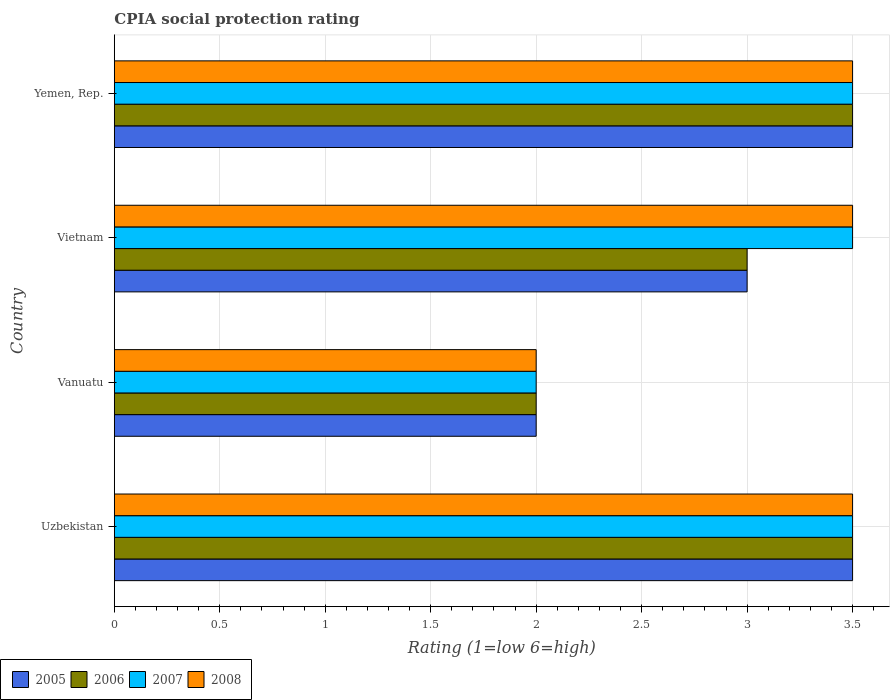How many different coloured bars are there?
Your answer should be compact. 4. How many groups of bars are there?
Provide a short and direct response. 4. Are the number of bars per tick equal to the number of legend labels?
Give a very brief answer. Yes. What is the label of the 2nd group of bars from the top?
Your answer should be compact. Vietnam. In how many cases, is the number of bars for a given country not equal to the number of legend labels?
Provide a short and direct response. 0. Across all countries, what is the minimum CPIA rating in 2008?
Ensure brevity in your answer.  2. In which country was the CPIA rating in 2007 maximum?
Offer a very short reply. Uzbekistan. In which country was the CPIA rating in 2008 minimum?
Make the answer very short. Vanuatu. What is the average CPIA rating in 2007 per country?
Your answer should be very brief. 3.12. What is the difference between the CPIA rating in 2006 and CPIA rating in 2005 in Vanuatu?
Make the answer very short. 0. In how many countries, is the CPIA rating in 2008 greater than 2.7 ?
Make the answer very short. 3. What is the ratio of the CPIA rating in 2007 in Vietnam to that in Yemen, Rep.?
Ensure brevity in your answer.  1. What is the difference between the highest and the second highest CPIA rating in 2007?
Offer a terse response. 0. What does the 2nd bar from the top in Vanuatu represents?
Offer a very short reply. 2007. What does the 2nd bar from the bottom in Uzbekistan represents?
Your answer should be compact. 2006. Is it the case that in every country, the sum of the CPIA rating in 2006 and CPIA rating in 2008 is greater than the CPIA rating in 2005?
Keep it short and to the point. Yes. How many bars are there?
Ensure brevity in your answer.  16. What is the difference between two consecutive major ticks on the X-axis?
Offer a terse response. 0.5. Are the values on the major ticks of X-axis written in scientific E-notation?
Offer a terse response. No. Does the graph contain any zero values?
Your answer should be very brief. No. Does the graph contain grids?
Give a very brief answer. Yes. How many legend labels are there?
Provide a succinct answer. 4. How are the legend labels stacked?
Your answer should be very brief. Horizontal. What is the title of the graph?
Provide a succinct answer. CPIA social protection rating. Does "1973" appear as one of the legend labels in the graph?
Provide a short and direct response. No. What is the label or title of the X-axis?
Your answer should be compact. Rating (1=low 6=high). What is the Rating (1=low 6=high) in 2007 in Uzbekistan?
Provide a short and direct response. 3.5. What is the Rating (1=low 6=high) of 2008 in Uzbekistan?
Make the answer very short. 3.5. What is the Rating (1=low 6=high) of 2005 in Vanuatu?
Provide a succinct answer. 2. What is the Rating (1=low 6=high) of 2005 in Vietnam?
Your response must be concise. 3. What is the Rating (1=low 6=high) of 2007 in Vietnam?
Offer a terse response. 3.5. What is the Rating (1=low 6=high) in 2008 in Vietnam?
Your answer should be very brief. 3.5. What is the Rating (1=low 6=high) in 2005 in Yemen, Rep.?
Provide a succinct answer. 3.5. What is the Rating (1=low 6=high) of 2007 in Yemen, Rep.?
Offer a very short reply. 3.5. Across all countries, what is the maximum Rating (1=low 6=high) of 2006?
Make the answer very short. 3.5. Across all countries, what is the maximum Rating (1=low 6=high) of 2007?
Your response must be concise. 3.5. Across all countries, what is the maximum Rating (1=low 6=high) of 2008?
Offer a terse response. 3.5. What is the total Rating (1=low 6=high) in 2005 in the graph?
Make the answer very short. 12. What is the total Rating (1=low 6=high) in 2008 in the graph?
Provide a short and direct response. 12.5. What is the difference between the Rating (1=low 6=high) of 2008 in Uzbekistan and that in Vanuatu?
Offer a very short reply. 1.5. What is the difference between the Rating (1=low 6=high) of 2006 in Uzbekistan and that in Vietnam?
Ensure brevity in your answer.  0.5. What is the difference between the Rating (1=low 6=high) of 2007 in Uzbekistan and that in Vietnam?
Provide a succinct answer. 0. What is the difference between the Rating (1=low 6=high) of 2005 in Uzbekistan and that in Yemen, Rep.?
Your response must be concise. 0. What is the difference between the Rating (1=low 6=high) of 2007 in Uzbekistan and that in Yemen, Rep.?
Your answer should be very brief. 0. What is the difference between the Rating (1=low 6=high) of 2005 in Vanuatu and that in Vietnam?
Ensure brevity in your answer.  -1. What is the difference between the Rating (1=low 6=high) in 2006 in Vanuatu and that in Vietnam?
Your answer should be compact. -1. What is the difference between the Rating (1=low 6=high) of 2005 in Vanuatu and that in Yemen, Rep.?
Give a very brief answer. -1.5. What is the difference between the Rating (1=low 6=high) in 2006 in Vanuatu and that in Yemen, Rep.?
Your answer should be very brief. -1.5. What is the difference between the Rating (1=low 6=high) of 2008 in Vanuatu and that in Yemen, Rep.?
Your answer should be compact. -1.5. What is the difference between the Rating (1=low 6=high) of 2005 in Vietnam and that in Yemen, Rep.?
Your response must be concise. -0.5. What is the difference between the Rating (1=low 6=high) in 2007 in Vietnam and that in Yemen, Rep.?
Make the answer very short. 0. What is the difference between the Rating (1=low 6=high) in 2005 in Uzbekistan and the Rating (1=low 6=high) in 2008 in Vanuatu?
Your answer should be compact. 1.5. What is the difference between the Rating (1=low 6=high) in 2005 in Uzbekistan and the Rating (1=low 6=high) in 2006 in Vietnam?
Your answer should be compact. 0.5. What is the difference between the Rating (1=low 6=high) of 2005 in Uzbekistan and the Rating (1=low 6=high) of 2007 in Vietnam?
Your answer should be compact. 0. What is the difference between the Rating (1=low 6=high) of 2005 in Uzbekistan and the Rating (1=low 6=high) of 2008 in Vietnam?
Keep it short and to the point. 0. What is the difference between the Rating (1=low 6=high) of 2006 in Uzbekistan and the Rating (1=low 6=high) of 2008 in Vietnam?
Your answer should be very brief. 0. What is the difference between the Rating (1=low 6=high) in 2005 in Uzbekistan and the Rating (1=low 6=high) in 2006 in Yemen, Rep.?
Keep it short and to the point. 0. What is the difference between the Rating (1=low 6=high) of 2005 in Vanuatu and the Rating (1=low 6=high) of 2006 in Vietnam?
Keep it short and to the point. -1. What is the difference between the Rating (1=low 6=high) of 2005 in Vanuatu and the Rating (1=low 6=high) of 2007 in Vietnam?
Give a very brief answer. -1.5. What is the difference between the Rating (1=low 6=high) of 2007 in Vanuatu and the Rating (1=low 6=high) of 2008 in Vietnam?
Make the answer very short. -1.5. What is the difference between the Rating (1=low 6=high) of 2005 in Vanuatu and the Rating (1=low 6=high) of 2007 in Yemen, Rep.?
Your answer should be very brief. -1.5. What is the difference between the Rating (1=low 6=high) in 2005 in Vanuatu and the Rating (1=low 6=high) in 2008 in Yemen, Rep.?
Give a very brief answer. -1.5. What is the difference between the Rating (1=low 6=high) of 2006 in Vanuatu and the Rating (1=low 6=high) of 2007 in Yemen, Rep.?
Your answer should be very brief. -1.5. What is the difference between the Rating (1=low 6=high) of 2005 in Vietnam and the Rating (1=low 6=high) of 2006 in Yemen, Rep.?
Provide a succinct answer. -0.5. What is the difference between the Rating (1=low 6=high) of 2005 in Vietnam and the Rating (1=low 6=high) of 2007 in Yemen, Rep.?
Give a very brief answer. -0.5. What is the difference between the Rating (1=low 6=high) in 2005 in Vietnam and the Rating (1=low 6=high) in 2008 in Yemen, Rep.?
Provide a short and direct response. -0.5. What is the difference between the Rating (1=low 6=high) in 2006 in Vietnam and the Rating (1=low 6=high) in 2007 in Yemen, Rep.?
Provide a succinct answer. -0.5. What is the difference between the Rating (1=low 6=high) in 2006 in Vietnam and the Rating (1=low 6=high) in 2008 in Yemen, Rep.?
Keep it short and to the point. -0.5. What is the difference between the Rating (1=low 6=high) in 2007 in Vietnam and the Rating (1=low 6=high) in 2008 in Yemen, Rep.?
Offer a terse response. 0. What is the average Rating (1=low 6=high) in 2006 per country?
Your response must be concise. 3. What is the average Rating (1=low 6=high) of 2007 per country?
Your answer should be very brief. 3.12. What is the average Rating (1=low 6=high) of 2008 per country?
Ensure brevity in your answer.  3.12. What is the difference between the Rating (1=low 6=high) in 2005 and Rating (1=low 6=high) in 2007 in Uzbekistan?
Keep it short and to the point. 0. What is the difference between the Rating (1=low 6=high) in 2006 and Rating (1=low 6=high) in 2008 in Uzbekistan?
Offer a very short reply. 0. What is the difference between the Rating (1=low 6=high) in 2007 and Rating (1=low 6=high) in 2008 in Uzbekistan?
Provide a succinct answer. 0. What is the difference between the Rating (1=low 6=high) of 2005 and Rating (1=low 6=high) of 2006 in Vanuatu?
Provide a succinct answer. 0. What is the difference between the Rating (1=low 6=high) in 2005 and Rating (1=low 6=high) in 2007 in Vanuatu?
Make the answer very short. 0. What is the difference between the Rating (1=low 6=high) in 2005 and Rating (1=low 6=high) in 2008 in Vanuatu?
Ensure brevity in your answer.  0. What is the difference between the Rating (1=low 6=high) in 2006 and Rating (1=low 6=high) in 2007 in Vanuatu?
Your response must be concise. 0. What is the difference between the Rating (1=low 6=high) of 2007 and Rating (1=low 6=high) of 2008 in Vanuatu?
Provide a succinct answer. 0. What is the difference between the Rating (1=low 6=high) in 2005 and Rating (1=low 6=high) in 2008 in Vietnam?
Ensure brevity in your answer.  -0.5. What is the difference between the Rating (1=low 6=high) in 2006 and Rating (1=low 6=high) in 2007 in Vietnam?
Give a very brief answer. -0.5. What is the difference between the Rating (1=low 6=high) of 2006 and Rating (1=low 6=high) of 2008 in Vietnam?
Keep it short and to the point. -0.5. What is the difference between the Rating (1=low 6=high) of 2007 and Rating (1=low 6=high) of 2008 in Vietnam?
Give a very brief answer. 0. What is the difference between the Rating (1=low 6=high) of 2005 and Rating (1=low 6=high) of 2008 in Yemen, Rep.?
Your answer should be compact. 0. What is the difference between the Rating (1=low 6=high) of 2006 and Rating (1=low 6=high) of 2007 in Yemen, Rep.?
Keep it short and to the point. 0. What is the difference between the Rating (1=low 6=high) of 2007 and Rating (1=low 6=high) of 2008 in Yemen, Rep.?
Your answer should be very brief. 0. What is the ratio of the Rating (1=low 6=high) of 2005 in Uzbekistan to that in Vanuatu?
Make the answer very short. 1.75. What is the ratio of the Rating (1=low 6=high) in 2008 in Uzbekistan to that in Vietnam?
Make the answer very short. 1. What is the ratio of the Rating (1=low 6=high) of 2006 in Uzbekistan to that in Yemen, Rep.?
Give a very brief answer. 1. What is the ratio of the Rating (1=low 6=high) in 2008 in Uzbekistan to that in Yemen, Rep.?
Offer a terse response. 1. What is the ratio of the Rating (1=low 6=high) of 2005 in Vanuatu to that in Vietnam?
Your answer should be compact. 0.67. What is the ratio of the Rating (1=low 6=high) in 2006 in Vanuatu to that in Vietnam?
Keep it short and to the point. 0.67. What is the ratio of the Rating (1=low 6=high) of 2008 in Vanuatu to that in Vietnam?
Your response must be concise. 0.57. What is the ratio of the Rating (1=low 6=high) of 2006 in Vanuatu to that in Yemen, Rep.?
Your answer should be compact. 0.57. What is the ratio of the Rating (1=low 6=high) of 2007 in Vanuatu to that in Yemen, Rep.?
Provide a short and direct response. 0.57. What is the ratio of the Rating (1=low 6=high) in 2007 in Vietnam to that in Yemen, Rep.?
Give a very brief answer. 1. What is the ratio of the Rating (1=low 6=high) of 2008 in Vietnam to that in Yemen, Rep.?
Provide a succinct answer. 1. What is the difference between the highest and the second highest Rating (1=low 6=high) of 2005?
Provide a succinct answer. 0. What is the difference between the highest and the second highest Rating (1=low 6=high) in 2006?
Offer a very short reply. 0. What is the difference between the highest and the second highest Rating (1=low 6=high) of 2007?
Offer a very short reply. 0. What is the difference between the highest and the second highest Rating (1=low 6=high) of 2008?
Keep it short and to the point. 0. What is the difference between the highest and the lowest Rating (1=low 6=high) of 2006?
Your answer should be compact. 1.5. What is the difference between the highest and the lowest Rating (1=low 6=high) of 2007?
Keep it short and to the point. 1.5. 